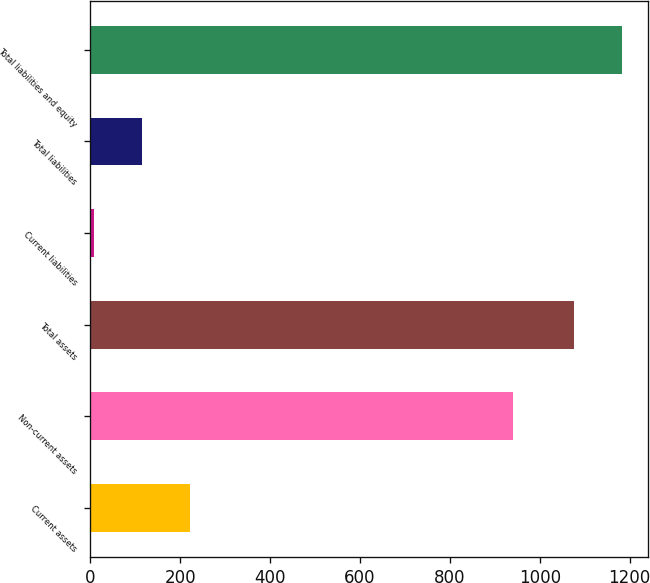<chart> <loc_0><loc_0><loc_500><loc_500><bar_chart><fcel>Current assets<fcel>Non-current assets<fcel>Total assets<fcel>Current liabilities<fcel>Total liabilities<fcel>Total liabilities and equity<nl><fcel>221.26<fcel>941.3<fcel>1075.1<fcel>7.8<fcel>114.53<fcel>1181.83<nl></chart> 